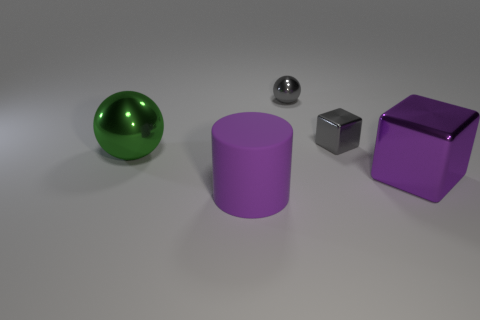There is a large shiny object left of the large cylinder; does it have the same shape as the big rubber thing?
Your response must be concise. No. What is the color of the large sphere that is made of the same material as the tiny sphere?
Your response must be concise. Green. Are there any big purple metallic cubes that are to the left of the tiny object in front of the tiny gray ball that is behind the small gray cube?
Ensure brevity in your answer.  No. The large green thing has what shape?
Your answer should be compact. Sphere. Are there fewer small spheres on the right side of the purple metal object than big rubber things?
Provide a succinct answer. Yes. Are there any small gray metallic objects of the same shape as the purple metallic object?
Ensure brevity in your answer.  Yes. What is the shape of the purple shiny thing that is the same size as the rubber thing?
Your response must be concise. Cube. How many objects are either purple matte objects or purple metal cubes?
Your response must be concise. 2. Are there any large metallic objects?
Make the answer very short. Yes. Are there fewer large green metallic things than gray metal objects?
Your response must be concise. Yes. 